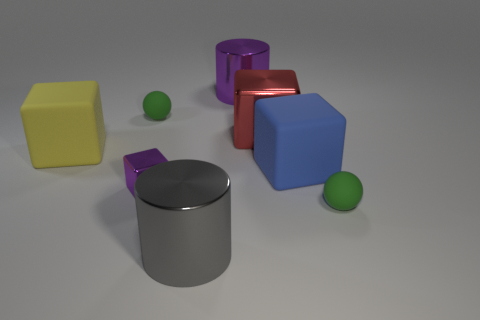What is the material of the yellow cube?
Your answer should be compact. Rubber. What number of balls are small brown things or purple things?
Ensure brevity in your answer.  0. Are the blue cube and the gray object made of the same material?
Make the answer very short. No. The purple metallic thing that is the same shape as the large red metallic object is what size?
Make the answer very short. Small. What is the material of the block that is behind the big blue rubber thing and on the left side of the purple cylinder?
Ensure brevity in your answer.  Rubber. Are there the same number of cubes to the left of the yellow thing and tiny matte objects?
Keep it short and to the point. No. What number of things are small green matte things left of the big red object or shiny cylinders?
Offer a terse response. 3. There is a metal cylinder that is behind the small metal block; is its color the same as the tiny shiny thing?
Give a very brief answer. Yes. What is the size of the purple shiny object on the left side of the purple cylinder?
Provide a succinct answer. Small. What shape is the tiny matte thing behind the small matte object that is on the right side of the blue rubber block?
Provide a succinct answer. Sphere. 